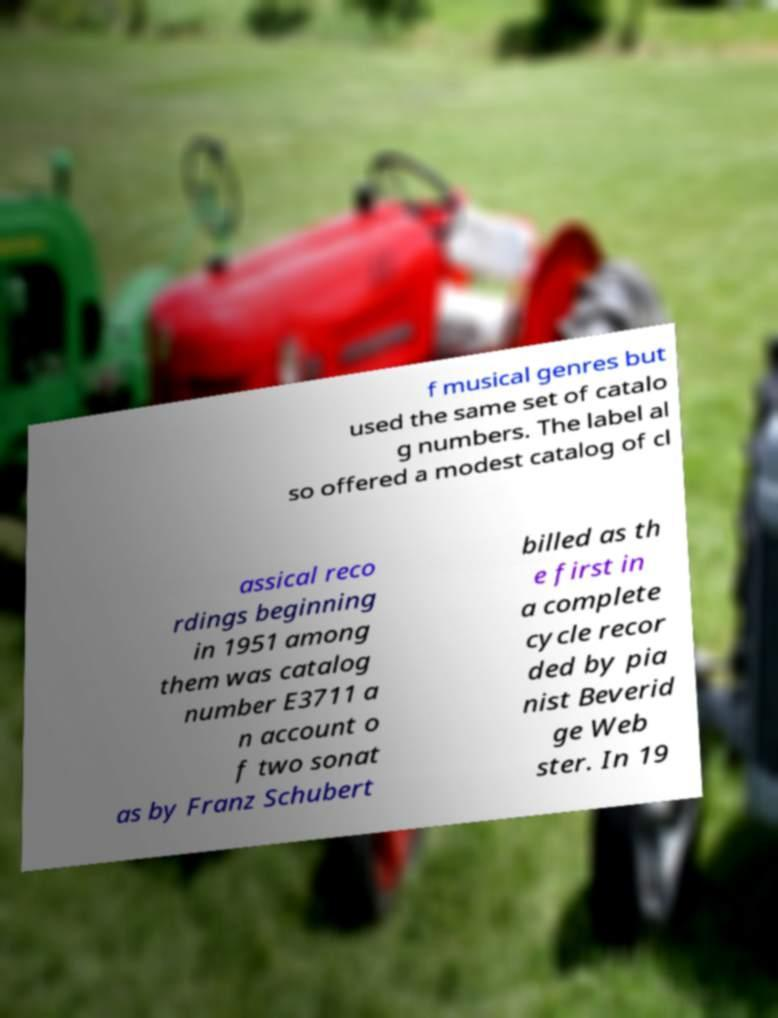Please identify and transcribe the text found in this image. f musical genres but used the same set of catalo g numbers. The label al so offered a modest catalog of cl assical reco rdings beginning in 1951 among them was catalog number E3711 a n account o f two sonat as by Franz Schubert billed as th e first in a complete cycle recor ded by pia nist Beverid ge Web ster. In 19 